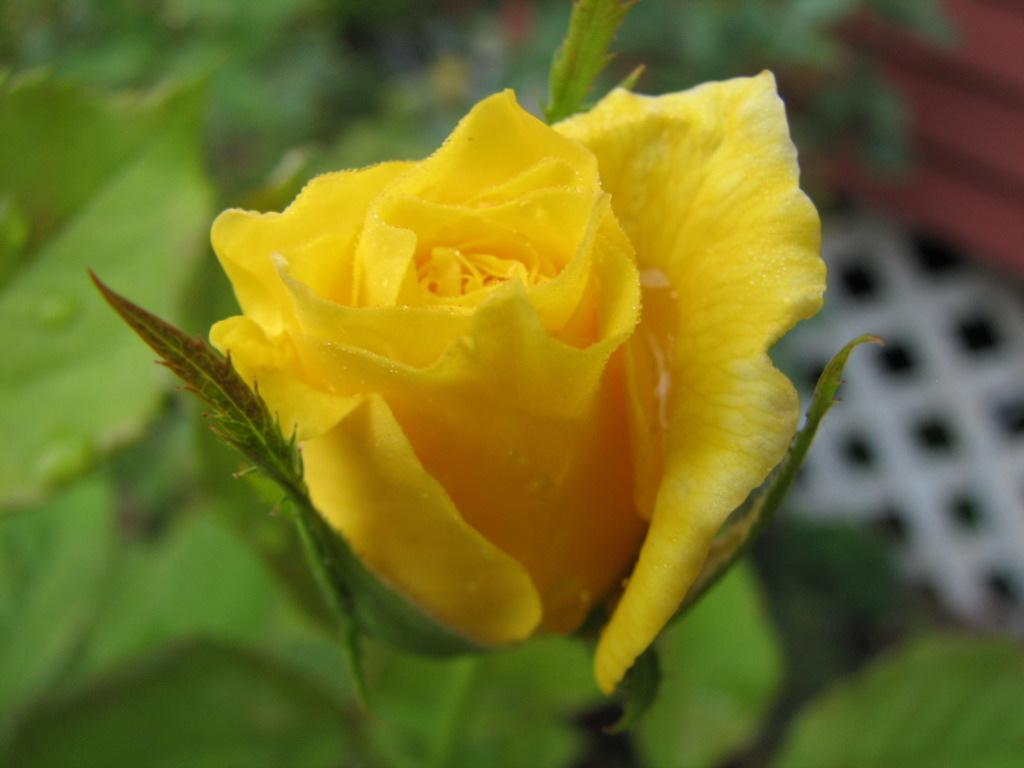What type of flower is in the image? There is a yellow flower in the image. Can you describe the background of the image? The background of the image is blurred. What type of harmony can be heard in the background of the image? There is no sound or music present in the image, so it is not possible to determine what type of harmony might be heard. 